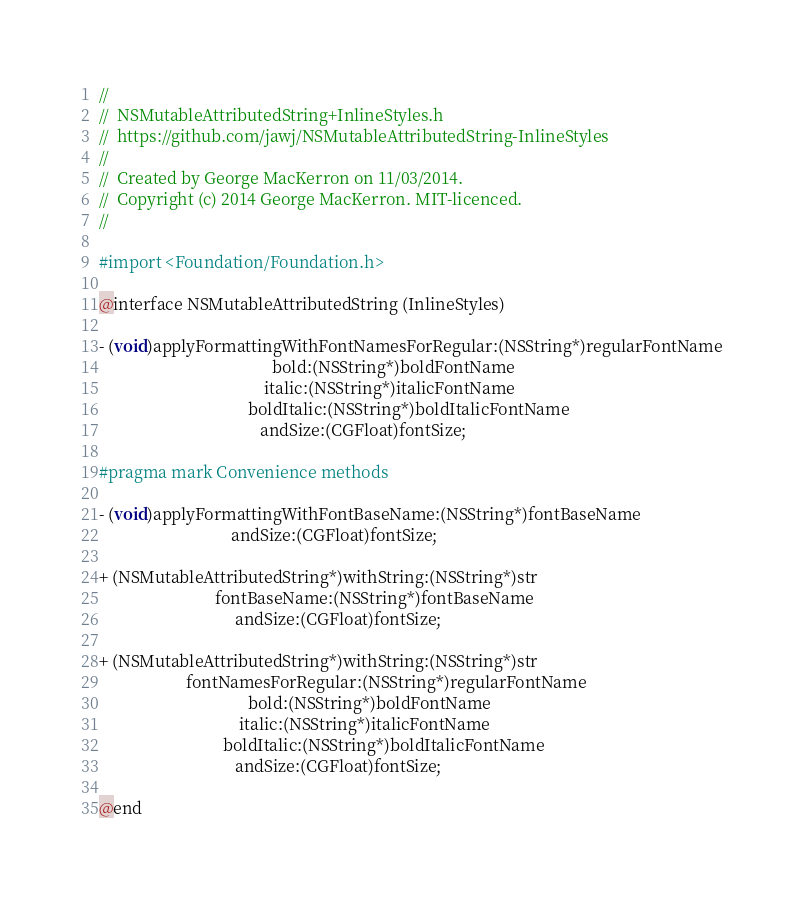<code> <loc_0><loc_0><loc_500><loc_500><_C_>//
//  NSMutableAttributedString+InlineStyles.h
//  https://github.com/jawj/NSMutableAttributedString-InlineStyles
//
//  Created by George MacKerron on 11/03/2014.
//  Copyright (c) 2014 George MacKerron. MIT-licenced.
//

#import <Foundation/Foundation.h>

@interface NSMutableAttributedString (InlineStyles)

- (void)applyFormattingWithFontNamesForRegular:(NSString*)regularFontName
                                          bold:(NSString*)boldFontName
                                        italic:(NSString*)italicFontName
                                    boldItalic:(NSString*)boldItalicFontName
                                       andSize:(CGFloat)fontSize;

#pragma mark Convenience methods

- (void)applyFormattingWithFontBaseName:(NSString*)fontBaseName
                                andSize:(CGFloat)fontSize;

+ (NSMutableAttributedString*)withString:(NSString*)str
                            fontBaseName:(NSString*)fontBaseName
                                 andSize:(CGFloat)fontSize;

+ (NSMutableAttributedString*)withString:(NSString*)str
                     fontNamesForRegular:(NSString*)regularFontName
                                    bold:(NSString*)boldFontName
                                  italic:(NSString*)italicFontName
                              boldItalic:(NSString*)boldItalicFontName
                                 andSize:(CGFloat)fontSize;

@end
</code> 